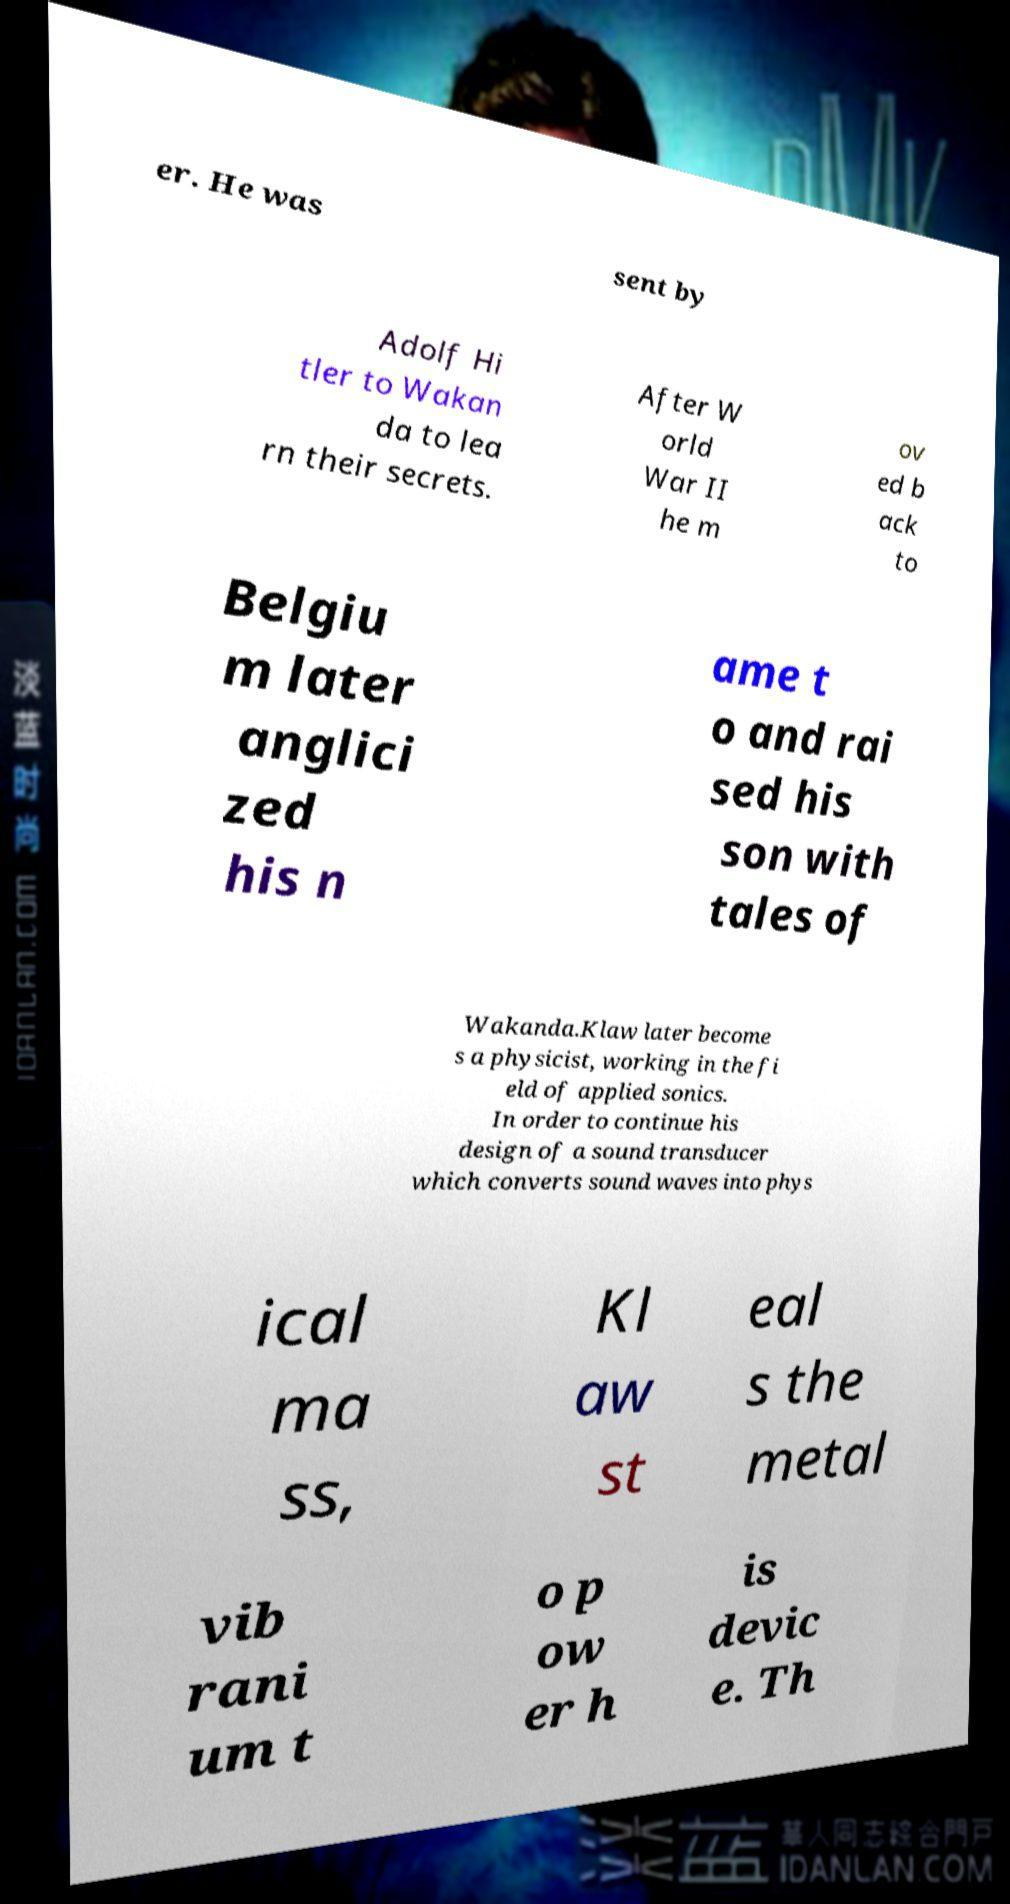I need the written content from this picture converted into text. Can you do that? er. He was sent by Adolf Hi tler to Wakan da to lea rn their secrets. After W orld War II he m ov ed b ack to Belgiu m later anglici zed his n ame t o and rai sed his son with tales of Wakanda.Klaw later become s a physicist, working in the fi eld of applied sonics. In order to continue his design of a sound transducer which converts sound waves into phys ical ma ss, Kl aw st eal s the metal vib rani um t o p ow er h is devic e. Th 